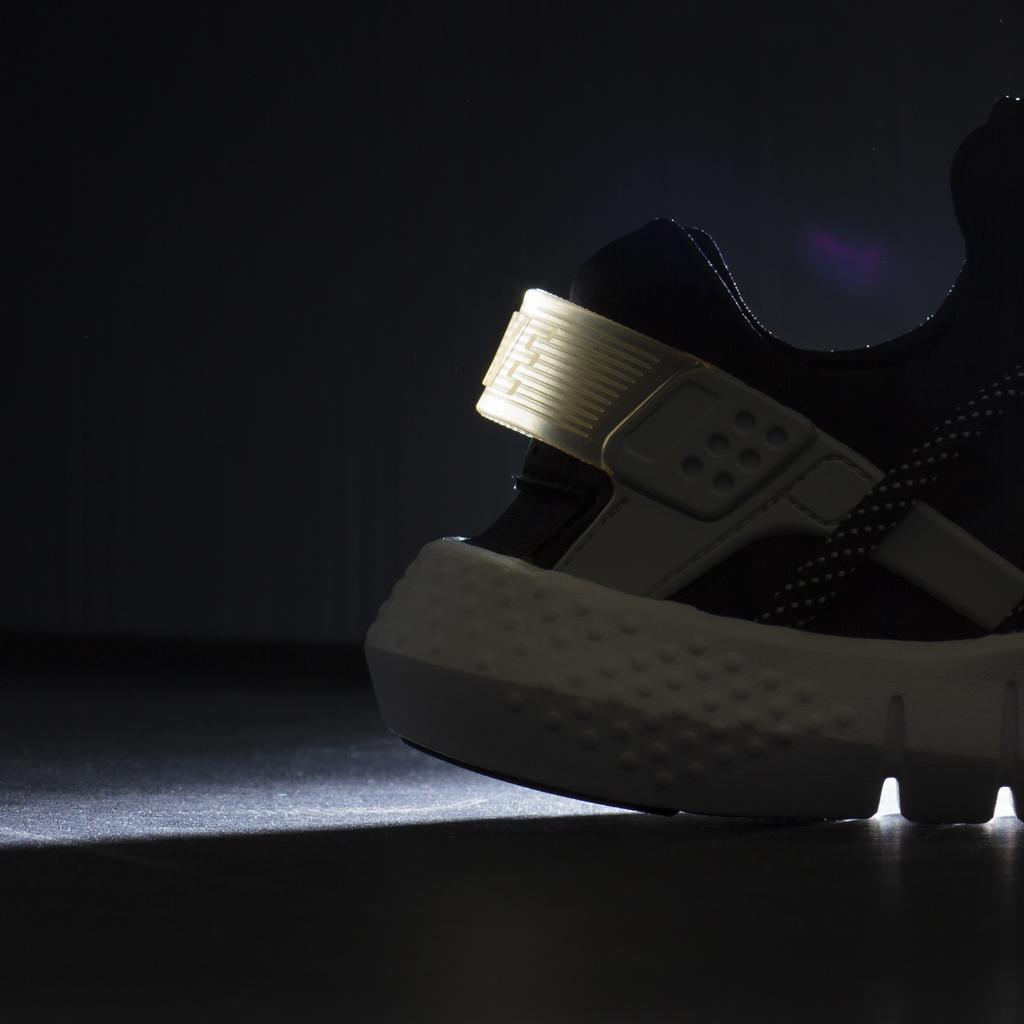Please provide a concise description of this image. In this image we can see a shoe on the floor. 